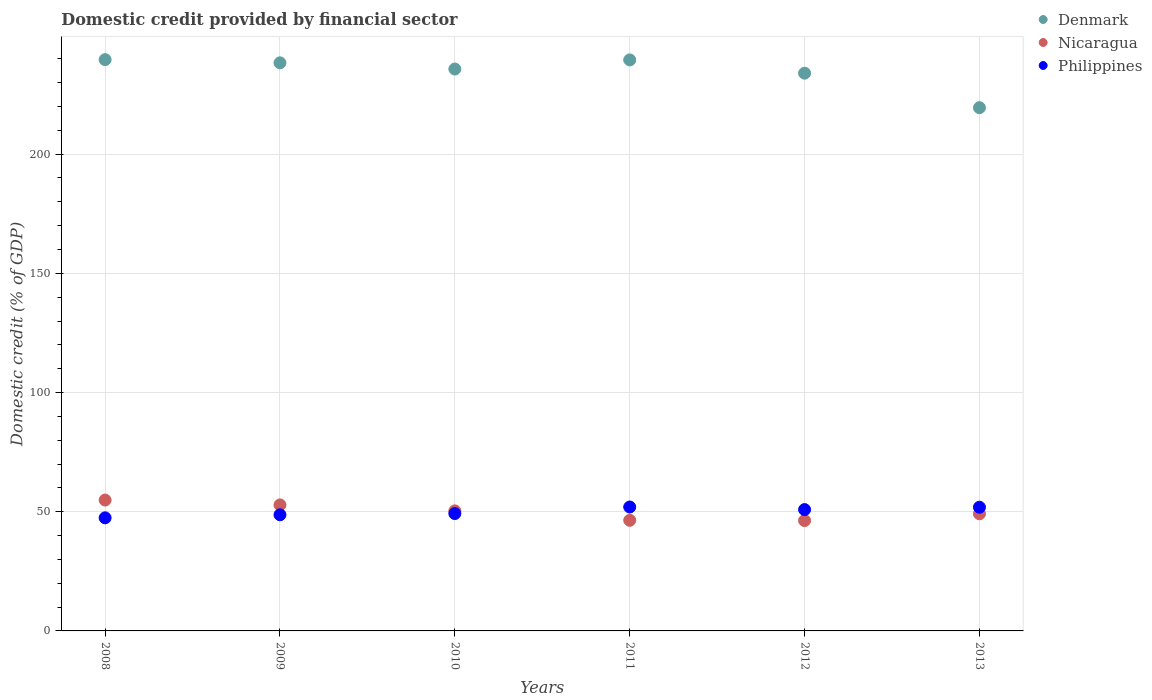Is the number of dotlines equal to the number of legend labels?
Ensure brevity in your answer.  Yes. What is the domestic credit in Nicaragua in 2008?
Offer a very short reply. 54.89. Across all years, what is the maximum domestic credit in Nicaragua?
Provide a succinct answer. 54.89. Across all years, what is the minimum domestic credit in Philippines?
Make the answer very short. 47.44. In which year was the domestic credit in Nicaragua maximum?
Offer a very short reply. 2008. What is the total domestic credit in Philippines in the graph?
Offer a very short reply. 300.15. What is the difference between the domestic credit in Nicaragua in 2010 and that in 2013?
Offer a very short reply. 1.22. What is the difference between the domestic credit in Philippines in 2011 and the domestic credit in Denmark in 2013?
Ensure brevity in your answer.  -167.5. What is the average domestic credit in Philippines per year?
Keep it short and to the point. 50.03. In the year 2010, what is the difference between the domestic credit in Philippines and domestic credit in Nicaragua?
Offer a terse response. -1.13. In how many years, is the domestic credit in Nicaragua greater than 10 %?
Offer a very short reply. 6. What is the ratio of the domestic credit in Denmark in 2010 to that in 2012?
Make the answer very short. 1.01. Is the domestic credit in Nicaragua in 2008 less than that in 2013?
Offer a terse response. No. Is the difference between the domestic credit in Philippines in 2010 and 2011 greater than the difference between the domestic credit in Nicaragua in 2010 and 2011?
Keep it short and to the point. No. What is the difference between the highest and the second highest domestic credit in Philippines?
Your answer should be compact. 0.1. What is the difference between the highest and the lowest domestic credit in Nicaragua?
Ensure brevity in your answer.  8.61. In how many years, is the domestic credit in Denmark greater than the average domestic credit in Denmark taken over all years?
Your response must be concise. 4. Is the sum of the domestic credit in Denmark in 2009 and 2013 greater than the maximum domestic credit in Nicaragua across all years?
Your response must be concise. Yes. Does the domestic credit in Denmark monotonically increase over the years?
Offer a very short reply. No. Is the domestic credit in Denmark strictly greater than the domestic credit in Philippines over the years?
Your response must be concise. Yes. Is the domestic credit in Denmark strictly less than the domestic credit in Philippines over the years?
Provide a succinct answer. No. How many dotlines are there?
Your answer should be very brief. 3. What is the difference between two consecutive major ticks on the Y-axis?
Offer a terse response. 50. Are the values on the major ticks of Y-axis written in scientific E-notation?
Offer a very short reply. No. Does the graph contain any zero values?
Keep it short and to the point. No. How many legend labels are there?
Provide a succinct answer. 3. How are the legend labels stacked?
Offer a terse response. Vertical. What is the title of the graph?
Keep it short and to the point. Domestic credit provided by financial sector. What is the label or title of the Y-axis?
Ensure brevity in your answer.  Domestic credit (% of GDP). What is the Domestic credit (% of GDP) in Denmark in 2008?
Keep it short and to the point. 239.64. What is the Domestic credit (% of GDP) in Nicaragua in 2008?
Your response must be concise. 54.89. What is the Domestic credit (% of GDP) of Philippines in 2008?
Keep it short and to the point. 47.44. What is the Domestic credit (% of GDP) in Denmark in 2009?
Your answer should be very brief. 238.3. What is the Domestic credit (% of GDP) of Nicaragua in 2009?
Your answer should be compact. 52.86. What is the Domestic credit (% of GDP) of Philippines in 2009?
Provide a short and direct response. 48.71. What is the Domestic credit (% of GDP) in Denmark in 2010?
Give a very brief answer. 235.69. What is the Domestic credit (% of GDP) of Nicaragua in 2010?
Your response must be concise. 50.36. What is the Domestic credit (% of GDP) in Philippines in 2010?
Offer a very short reply. 49.23. What is the Domestic credit (% of GDP) in Denmark in 2011?
Ensure brevity in your answer.  239.52. What is the Domestic credit (% of GDP) in Nicaragua in 2011?
Ensure brevity in your answer.  46.4. What is the Domestic credit (% of GDP) in Philippines in 2011?
Your answer should be very brief. 51.98. What is the Domestic credit (% of GDP) of Denmark in 2012?
Your answer should be compact. 233.95. What is the Domestic credit (% of GDP) of Nicaragua in 2012?
Keep it short and to the point. 46.29. What is the Domestic credit (% of GDP) of Philippines in 2012?
Keep it short and to the point. 50.9. What is the Domestic credit (% of GDP) of Denmark in 2013?
Make the answer very short. 219.48. What is the Domestic credit (% of GDP) of Nicaragua in 2013?
Offer a terse response. 49.13. What is the Domestic credit (% of GDP) in Philippines in 2013?
Ensure brevity in your answer.  51.88. Across all years, what is the maximum Domestic credit (% of GDP) of Denmark?
Make the answer very short. 239.64. Across all years, what is the maximum Domestic credit (% of GDP) in Nicaragua?
Your answer should be very brief. 54.89. Across all years, what is the maximum Domestic credit (% of GDP) in Philippines?
Your response must be concise. 51.98. Across all years, what is the minimum Domestic credit (% of GDP) of Denmark?
Keep it short and to the point. 219.48. Across all years, what is the minimum Domestic credit (% of GDP) of Nicaragua?
Your answer should be compact. 46.29. Across all years, what is the minimum Domestic credit (% of GDP) in Philippines?
Provide a short and direct response. 47.44. What is the total Domestic credit (% of GDP) of Denmark in the graph?
Give a very brief answer. 1406.58. What is the total Domestic credit (% of GDP) in Nicaragua in the graph?
Provide a succinct answer. 299.93. What is the total Domestic credit (% of GDP) of Philippines in the graph?
Give a very brief answer. 300.15. What is the difference between the Domestic credit (% of GDP) of Denmark in 2008 and that in 2009?
Make the answer very short. 1.34. What is the difference between the Domestic credit (% of GDP) of Nicaragua in 2008 and that in 2009?
Offer a very short reply. 2.04. What is the difference between the Domestic credit (% of GDP) of Philippines in 2008 and that in 2009?
Keep it short and to the point. -1.27. What is the difference between the Domestic credit (% of GDP) in Denmark in 2008 and that in 2010?
Give a very brief answer. 3.95. What is the difference between the Domestic credit (% of GDP) in Nicaragua in 2008 and that in 2010?
Ensure brevity in your answer.  4.54. What is the difference between the Domestic credit (% of GDP) in Philippines in 2008 and that in 2010?
Keep it short and to the point. -1.79. What is the difference between the Domestic credit (% of GDP) of Denmark in 2008 and that in 2011?
Offer a terse response. 0.12. What is the difference between the Domestic credit (% of GDP) in Nicaragua in 2008 and that in 2011?
Keep it short and to the point. 8.49. What is the difference between the Domestic credit (% of GDP) of Philippines in 2008 and that in 2011?
Offer a very short reply. -4.54. What is the difference between the Domestic credit (% of GDP) in Denmark in 2008 and that in 2012?
Offer a terse response. 5.69. What is the difference between the Domestic credit (% of GDP) in Nicaragua in 2008 and that in 2012?
Offer a terse response. 8.61. What is the difference between the Domestic credit (% of GDP) of Philippines in 2008 and that in 2012?
Your answer should be compact. -3.46. What is the difference between the Domestic credit (% of GDP) of Denmark in 2008 and that in 2013?
Offer a very short reply. 20.16. What is the difference between the Domestic credit (% of GDP) in Nicaragua in 2008 and that in 2013?
Your response must be concise. 5.76. What is the difference between the Domestic credit (% of GDP) in Philippines in 2008 and that in 2013?
Give a very brief answer. -4.44. What is the difference between the Domestic credit (% of GDP) of Denmark in 2009 and that in 2010?
Keep it short and to the point. 2.61. What is the difference between the Domestic credit (% of GDP) of Nicaragua in 2009 and that in 2010?
Your answer should be very brief. 2.5. What is the difference between the Domestic credit (% of GDP) of Philippines in 2009 and that in 2010?
Make the answer very short. -0.52. What is the difference between the Domestic credit (% of GDP) of Denmark in 2009 and that in 2011?
Provide a short and direct response. -1.22. What is the difference between the Domestic credit (% of GDP) in Nicaragua in 2009 and that in 2011?
Your answer should be very brief. 6.46. What is the difference between the Domestic credit (% of GDP) in Philippines in 2009 and that in 2011?
Provide a short and direct response. -3.27. What is the difference between the Domestic credit (% of GDP) in Denmark in 2009 and that in 2012?
Make the answer very short. 4.35. What is the difference between the Domestic credit (% of GDP) of Nicaragua in 2009 and that in 2012?
Offer a very short reply. 6.57. What is the difference between the Domestic credit (% of GDP) of Philippines in 2009 and that in 2012?
Offer a terse response. -2.18. What is the difference between the Domestic credit (% of GDP) in Denmark in 2009 and that in 2013?
Ensure brevity in your answer.  18.82. What is the difference between the Domestic credit (% of GDP) in Nicaragua in 2009 and that in 2013?
Offer a very short reply. 3.72. What is the difference between the Domestic credit (% of GDP) of Philippines in 2009 and that in 2013?
Make the answer very short. -3.17. What is the difference between the Domestic credit (% of GDP) in Denmark in 2010 and that in 2011?
Offer a very short reply. -3.83. What is the difference between the Domestic credit (% of GDP) of Nicaragua in 2010 and that in 2011?
Provide a succinct answer. 3.96. What is the difference between the Domestic credit (% of GDP) of Philippines in 2010 and that in 2011?
Provide a short and direct response. -2.75. What is the difference between the Domestic credit (% of GDP) in Denmark in 2010 and that in 2012?
Your answer should be very brief. 1.74. What is the difference between the Domestic credit (% of GDP) of Nicaragua in 2010 and that in 2012?
Ensure brevity in your answer.  4.07. What is the difference between the Domestic credit (% of GDP) in Philippines in 2010 and that in 2012?
Give a very brief answer. -1.67. What is the difference between the Domestic credit (% of GDP) of Denmark in 2010 and that in 2013?
Provide a succinct answer. 16.21. What is the difference between the Domestic credit (% of GDP) of Nicaragua in 2010 and that in 2013?
Make the answer very short. 1.22. What is the difference between the Domestic credit (% of GDP) of Philippines in 2010 and that in 2013?
Offer a very short reply. -2.65. What is the difference between the Domestic credit (% of GDP) in Denmark in 2011 and that in 2012?
Provide a short and direct response. 5.57. What is the difference between the Domestic credit (% of GDP) of Nicaragua in 2011 and that in 2012?
Offer a terse response. 0.11. What is the difference between the Domestic credit (% of GDP) in Philippines in 2011 and that in 2012?
Your answer should be very brief. 1.08. What is the difference between the Domestic credit (% of GDP) of Denmark in 2011 and that in 2013?
Make the answer very short. 20.04. What is the difference between the Domestic credit (% of GDP) in Nicaragua in 2011 and that in 2013?
Your answer should be very brief. -2.74. What is the difference between the Domestic credit (% of GDP) in Philippines in 2011 and that in 2013?
Give a very brief answer. 0.1. What is the difference between the Domestic credit (% of GDP) in Denmark in 2012 and that in 2013?
Provide a succinct answer. 14.47. What is the difference between the Domestic credit (% of GDP) in Nicaragua in 2012 and that in 2013?
Your response must be concise. -2.85. What is the difference between the Domestic credit (% of GDP) in Philippines in 2012 and that in 2013?
Your answer should be very brief. -0.99. What is the difference between the Domestic credit (% of GDP) of Denmark in 2008 and the Domestic credit (% of GDP) of Nicaragua in 2009?
Ensure brevity in your answer.  186.79. What is the difference between the Domestic credit (% of GDP) in Denmark in 2008 and the Domestic credit (% of GDP) in Philippines in 2009?
Offer a very short reply. 190.93. What is the difference between the Domestic credit (% of GDP) of Nicaragua in 2008 and the Domestic credit (% of GDP) of Philippines in 2009?
Make the answer very short. 6.18. What is the difference between the Domestic credit (% of GDP) in Denmark in 2008 and the Domestic credit (% of GDP) in Nicaragua in 2010?
Your response must be concise. 189.28. What is the difference between the Domestic credit (% of GDP) in Denmark in 2008 and the Domestic credit (% of GDP) in Philippines in 2010?
Keep it short and to the point. 190.41. What is the difference between the Domestic credit (% of GDP) in Nicaragua in 2008 and the Domestic credit (% of GDP) in Philippines in 2010?
Make the answer very short. 5.66. What is the difference between the Domestic credit (% of GDP) of Denmark in 2008 and the Domestic credit (% of GDP) of Nicaragua in 2011?
Ensure brevity in your answer.  193.24. What is the difference between the Domestic credit (% of GDP) in Denmark in 2008 and the Domestic credit (% of GDP) in Philippines in 2011?
Offer a terse response. 187.66. What is the difference between the Domestic credit (% of GDP) in Nicaragua in 2008 and the Domestic credit (% of GDP) in Philippines in 2011?
Give a very brief answer. 2.91. What is the difference between the Domestic credit (% of GDP) in Denmark in 2008 and the Domestic credit (% of GDP) in Nicaragua in 2012?
Make the answer very short. 193.35. What is the difference between the Domestic credit (% of GDP) in Denmark in 2008 and the Domestic credit (% of GDP) in Philippines in 2012?
Provide a short and direct response. 188.74. What is the difference between the Domestic credit (% of GDP) of Nicaragua in 2008 and the Domestic credit (% of GDP) of Philippines in 2012?
Your answer should be very brief. 4. What is the difference between the Domestic credit (% of GDP) of Denmark in 2008 and the Domestic credit (% of GDP) of Nicaragua in 2013?
Your response must be concise. 190.51. What is the difference between the Domestic credit (% of GDP) of Denmark in 2008 and the Domestic credit (% of GDP) of Philippines in 2013?
Offer a very short reply. 187.76. What is the difference between the Domestic credit (% of GDP) of Nicaragua in 2008 and the Domestic credit (% of GDP) of Philippines in 2013?
Offer a terse response. 3.01. What is the difference between the Domestic credit (% of GDP) in Denmark in 2009 and the Domestic credit (% of GDP) in Nicaragua in 2010?
Provide a succinct answer. 187.94. What is the difference between the Domestic credit (% of GDP) in Denmark in 2009 and the Domestic credit (% of GDP) in Philippines in 2010?
Offer a very short reply. 189.07. What is the difference between the Domestic credit (% of GDP) of Nicaragua in 2009 and the Domestic credit (% of GDP) of Philippines in 2010?
Provide a succinct answer. 3.62. What is the difference between the Domestic credit (% of GDP) in Denmark in 2009 and the Domestic credit (% of GDP) in Nicaragua in 2011?
Make the answer very short. 191.9. What is the difference between the Domestic credit (% of GDP) in Denmark in 2009 and the Domestic credit (% of GDP) in Philippines in 2011?
Give a very brief answer. 186.32. What is the difference between the Domestic credit (% of GDP) of Nicaragua in 2009 and the Domestic credit (% of GDP) of Philippines in 2011?
Offer a very short reply. 0.88. What is the difference between the Domestic credit (% of GDP) of Denmark in 2009 and the Domestic credit (% of GDP) of Nicaragua in 2012?
Your answer should be compact. 192.01. What is the difference between the Domestic credit (% of GDP) in Denmark in 2009 and the Domestic credit (% of GDP) in Philippines in 2012?
Provide a short and direct response. 187.4. What is the difference between the Domestic credit (% of GDP) in Nicaragua in 2009 and the Domestic credit (% of GDP) in Philippines in 2012?
Your answer should be compact. 1.96. What is the difference between the Domestic credit (% of GDP) in Denmark in 2009 and the Domestic credit (% of GDP) in Nicaragua in 2013?
Give a very brief answer. 189.17. What is the difference between the Domestic credit (% of GDP) in Denmark in 2009 and the Domestic credit (% of GDP) in Philippines in 2013?
Offer a terse response. 186.42. What is the difference between the Domestic credit (% of GDP) of Nicaragua in 2009 and the Domestic credit (% of GDP) of Philippines in 2013?
Keep it short and to the point. 0.97. What is the difference between the Domestic credit (% of GDP) in Denmark in 2010 and the Domestic credit (% of GDP) in Nicaragua in 2011?
Your response must be concise. 189.29. What is the difference between the Domestic credit (% of GDP) in Denmark in 2010 and the Domestic credit (% of GDP) in Philippines in 2011?
Your answer should be very brief. 183.71. What is the difference between the Domestic credit (% of GDP) of Nicaragua in 2010 and the Domestic credit (% of GDP) of Philippines in 2011?
Provide a short and direct response. -1.62. What is the difference between the Domestic credit (% of GDP) of Denmark in 2010 and the Domestic credit (% of GDP) of Nicaragua in 2012?
Your answer should be very brief. 189.4. What is the difference between the Domestic credit (% of GDP) in Denmark in 2010 and the Domestic credit (% of GDP) in Philippines in 2012?
Make the answer very short. 184.79. What is the difference between the Domestic credit (% of GDP) of Nicaragua in 2010 and the Domestic credit (% of GDP) of Philippines in 2012?
Offer a very short reply. -0.54. What is the difference between the Domestic credit (% of GDP) of Denmark in 2010 and the Domestic credit (% of GDP) of Nicaragua in 2013?
Your answer should be very brief. 186.56. What is the difference between the Domestic credit (% of GDP) in Denmark in 2010 and the Domestic credit (% of GDP) in Philippines in 2013?
Offer a terse response. 183.81. What is the difference between the Domestic credit (% of GDP) in Nicaragua in 2010 and the Domestic credit (% of GDP) in Philippines in 2013?
Provide a succinct answer. -1.53. What is the difference between the Domestic credit (% of GDP) in Denmark in 2011 and the Domestic credit (% of GDP) in Nicaragua in 2012?
Your response must be concise. 193.23. What is the difference between the Domestic credit (% of GDP) of Denmark in 2011 and the Domestic credit (% of GDP) of Philippines in 2012?
Give a very brief answer. 188.62. What is the difference between the Domestic credit (% of GDP) in Nicaragua in 2011 and the Domestic credit (% of GDP) in Philippines in 2012?
Keep it short and to the point. -4.5. What is the difference between the Domestic credit (% of GDP) in Denmark in 2011 and the Domestic credit (% of GDP) in Nicaragua in 2013?
Your answer should be compact. 190.39. What is the difference between the Domestic credit (% of GDP) in Denmark in 2011 and the Domestic credit (% of GDP) in Philippines in 2013?
Ensure brevity in your answer.  187.64. What is the difference between the Domestic credit (% of GDP) of Nicaragua in 2011 and the Domestic credit (% of GDP) of Philippines in 2013?
Your answer should be very brief. -5.49. What is the difference between the Domestic credit (% of GDP) in Denmark in 2012 and the Domestic credit (% of GDP) in Nicaragua in 2013?
Give a very brief answer. 184.82. What is the difference between the Domestic credit (% of GDP) in Denmark in 2012 and the Domestic credit (% of GDP) in Philippines in 2013?
Offer a terse response. 182.07. What is the difference between the Domestic credit (% of GDP) in Nicaragua in 2012 and the Domestic credit (% of GDP) in Philippines in 2013?
Give a very brief answer. -5.6. What is the average Domestic credit (% of GDP) of Denmark per year?
Your response must be concise. 234.43. What is the average Domestic credit (% of GDP) in Nicaragua per year?
Offer a terse response. 49.99. What is the average Domestic credit (% of GDP) in Philippines per year?
Keep it short and to the point. 50.03. In the year 2008, what is the difference between the Domestic credit (% of GDP) in Denmark and Domestic credit (% of GDP) in Nicaragua?
Your answer should be very brief. 184.75. In the year 2008, what is the difference between the Domestic credit (% of GDP) of Denmark and Domestic credit (% of GDP) of Philippines?
Offer a very short reply. 192.2. In the year 2008, what is the difference between the Domestic credit (% of GDP) in Nicaragua and Domestic credit (% of GDP) in Philippines?
Offer a very short reply. 7.45. In the year 2009, what is the difference between the Domestic credit (% of GDP) of Denmark and Domestic credit (% of GDP) of Nicaragua?
Make the answer very short. 185.44. In the year 2009, what is the difference between the Domestic credit (% of GDP) in Denmark and Domestic credit (% of GDP) in Philippines?
Offer a terse response. 189.59. In the year 2009, what is the difference between the Domestic credit (% of GDP) of Nicaragua and Domestic credit (% of GDP) of Philippines?
Your response must be concise. 4.14. In the year 2010, what is the difference between the Domestic credit (% of GDP) in Denmark and Domestic credit (% of GDP) in Nicaragua?
Offer a very short reply. 185.33. In the year 2010, what is the difference between the Domestic credit (% of GDP) of Denmark and Domestic credit (% of GDP) of Philippines?
Ensure brevity in your answer.  186.46. In the year 2010, what is the difference between the Domestic credit (% of GDP) in Nicaragua and Domestic credit (% of GDP) in Philippines?
Keep it short and to the point. 1.13. In the year 2011, what is the difference between the Domestic credit (% of GDP) of Denmark and Domestic credit (% of GDP) of Nicaragua?
Provide a succinct answer. 193.12. In the year 2011, what is the difference between the Domestic credit (% of GDP) of Denmark and Domestic credit (% of GDP) of Philippines?
Your answer should be compact. 187.54. In the year 2011, what is the difference between the Domestic credit (% of GDP) in Nicaragua and Domestic credit (% of GDP) in Philippines?
Make the answer very short. -5.58. In the year 2012, what is the difference between the Domestic credit (% of GDP) of Denmark and Domestic credit (% of GDP) of Nicaragua?
Provide a short and direct response. 187.66. In the year 2012, what is the difference between the Domestic credit (% of GDP) of Denmark and Domestic credit (% of GDP) of Philippines?
Your answer should be very brief. 183.05. In the year 2012, what is the difference between the Domestic credit (% of GDP) of Nicaragua and Domestic credit (% of GDP) of Philippines?
Give a very brief answer. -4.61. In the year 2013, what is the difference between the Domestic credit (% of GDP) of Denmark and Domestic credit (% of GDP) of Nicaragua?
Provide a short and direct response. 170.34. In the year 2013, what is the difference between the Domestic credit (% of GDP) of Denmark and Domestic credit (% of GDP) of Philippines?
Your answer should be compact. 167.59. In the year 2013, what is the difference between the Domestic credit (% of GDP) in Nicaragua and Domestic credit (% of GDP) in Philippines?
Make the answer very short. -2.75. What is the ratio of the Domestic credit (% of GDP) of Denmark in 2008 to that in 2009?
Make the answer very short. 1.01. What is the ratio of the Domestic credit (% of GDP) of Nicaragua in 2008 to that in 2009?
Provide a succinct answer. 1.04. What is the ratio of the Domestic credit (% of GDP) of Philippines in 2008 to that in 2009?
Give a very brief answer. 0.97. What is the ratio of the Domestic credit (% of GDP) in Denmark in 2008 to that in 2010?
Give a very brief answer. 1.02. What is the ratio of the Domestic credit (% of GDP) of Nicaragua in 2008 to that in 2010?
Ensure brevity in your answer.  1.09. What is the ratio of the Domestic credit (% of GDP) of Philippines in 2008 to that in 2010?
Provide a short and direct response. 0.96. What is the ratio of the Domestic credit (% of GDP) of Denmark in 2008 to that in 2011?
Make the answer very short. 1. What is the ratio of the Domestic credit (% of GDP) of Nicaragua in 2008 to that in 2011?
Provide a short and direct response. 1.18. What is the ratio of the Domestic credit (% of GDP) of Philippines in 2008 to that in 2011?
Offer a very short reply. 0.91. What is the ratio of the Domestic credit (% of GDP) of Denmark in 2008 to that in 2012?
Ensure brevity in your answer.  1.02. What is the ratio of the Domestic credit (% of GDP) of Nicaragua in 2008 to that in 2012?
Keep it short and to the point. 1.19. What is the ratio of the Domestic credit (% of GDP) in Philippines in 2008 to that in 2012?
Make the answer very short. 0.93. What is the ratio of the Domestic credit (% of GDP) in Denmark in 2008 to that in 2013?
Offer a terse response. 1.09. What is the ratio of the Domestic credit (% of GDP) of Nicaragua in 2008 to that in 2013?
Keep it short and to the point. 1.12. What is the ratio of the Domestic credit (% of GDP) of Philippines in 2008 to that in 2013?
Your answer should be compact. 0.91. What is the ratio of the Domestic credit (% of GDP) of Denmark in 2009 to that in 2010?
Make the answer very short. 1.01. What is the ratio of the Domestic credit (% of GDP) in Nicaragua in 2009 to that in 2010?
Your answer should be very brief. 1.05. What is the ratio of the Domestic credit (% of GDP) in Denmark in 2009 to that in 2011?
Make the answer very short. 0.99. What is the ratio of the Domestic credit (% of GDP) in Nicaragua in 2009 to that in 2011?
Provide a short and direct response. 1.14. What is the ratio of the Domestic credit (% of GDP) of Philippines in 2009 to that in 2011?
Offer a terse response. 0.94. What is the ratio of the Domestic credit (% of GDP) in Denmark in 2009 to that in 2012?
Your answer should be compact. 1.02. What is the ratio of the Domestic credit (% of GDP) of Nicaragua in 2009 to that in 2012?
Provide a succinct answer. 1.14. What is the ratio of the Domestic credit (% of GDP) of Philippines in 2009 to that in 2012?
Ensure brevity in your answer.  0.96. What is the ratio of the Domestic credit (% of GDP) of Denmark in 2009 to that in 2013?
Ensure brevity in your answer.  1.09. What is the ratio of the Domestic credit (% of GDP) of Nicaragua in 2009 to that in 2013?
Offer a terse response. 1.08. What is the ratio of the Domestic credit (% of GDP) of Philippines in 2009 to that in 2013?
Your answer should be very brief. 0.94. What is the ratio of the Domestic credit (% of GDP) in Denmark in 2010 to that in 2011?
Your response must be concise. 0.98. What is the ratio of the Domestic credit (% of GDP) of Nicaragua in 2010 to that in 2011?
Provide a succinct answer. 1.09. What is the ratio of the Domestic credit (% of GDP) of Philippines in 2010 to that in 2011?
Make the answer very short. 0.95. What is the ratio of the Domestic credit (% of GDP) of Denmark in 2010 to that in 2012?
Make the answer very short. 1.01. What is the ratio of the Domestic credit (% of GDP) in Nicaragua in 2010 to that in 2012?
Your answer should be compact. 1.09. What is the ratio of the Domestic credit (% of GDP) in Philippines in 2010 to that in 2012?
Keep it short and to the point. 0.97. What is the ratio of the Domestic credit (% of GDP) in Denmark in 2010 to that in 2013?
Provide a succinct answer. 1.07. What is the ratio of the Domestic credit (% of GDP) in Nicaragua in 2010 to that in 2013?
Your answer should be very brief. 1.02. What is the ratio of the Domestic credit (% of GDP) of Philippines in 2010 to that in 2013?
Your answer should be compact. 0.95. What is the ratio of the Domestic credit (% of GDP) of Denmark in 2011 to that in 2012?
Keep it short and to the point. 1.02. What is the ratio of the Domestic credit (% of GDP) in Nicaragua in 2011 to that in 2012?
Offer a terse response. 1. What is the ratio of the Domestic credit (% of GDP) in Philippines in 2011 to that in 2012?
Your response must be concise. 1.02. What is the ratio of the Domestic credit (% of GDP) of Denmark in 2011 to that in 2013?
Your answer should be very brief. 1.09. What is the ratio of the Domestic credit (% of GDP) in Nicaragua in 2011 to that in 2013?
Offer a terse response. 0.94. What is the ratio of the Domestic credit (% of GDP) in Philippines in 2011 to that in 2013?
Your answer should be very brief. 1. What is the ratio of the Domestic credit (% of GDP) of Denmark in 2012 to that in 2013?
Your response must be concise. 1.07. What is the ratio of the Domestic credit (% of GDP) of Nicaragua in 2012 to that in 2013?
Offer a terse response. 0.94. What is the difference between the highest and the second highest Domestic credit (% of GDP) in Denmark?
Keep it short and to the point. 0.12. What is the difference between the highest and the second highest Domestic credit (% of GDP) of Nicaragua?
Make the answer very short. 2.04. What is the difference between the highest and the second highest Domestic credit (% of GDP) in Philippines?
Make the answer very short. 0.1. What is the difference between the highest and the lowest Domestic credit (% of GDP) of Denmark?
Offer a very short reply. 20.16. What is the difference between the highest and the lowest Domestic credit (% of GDP) of Nicaragua?
Provide a short and direct response. 8.61. What is the difference between the highest and the lowest Domestic credit (% of GDP) of Philippines?
Give a very brief answer. 4.54. 